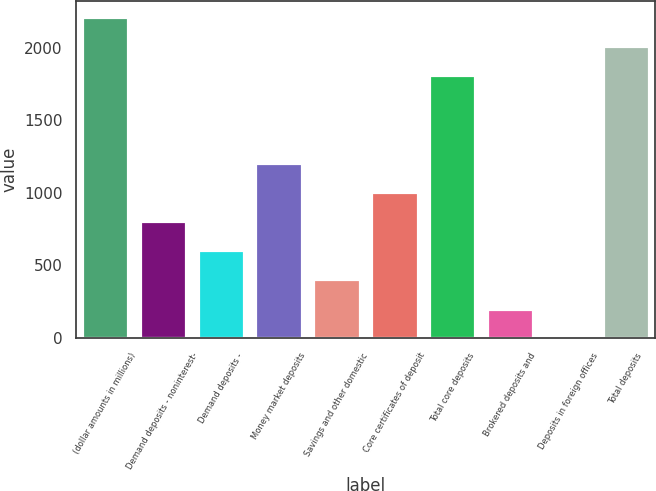Convert chart. <chart><loc_0><loc_0><loc_500><loc_500><bar_chart><fcel>(dollar amounts in millions)<fcel>Demand deposits - noninterest-<fcel>Demand deposits -<fcel>Money market deposits<fcel>Savings and other domestic<fcel>Core certificates of deposit<fcel>Total core deposits<fcel>Brokered deposits and<fcel>Deposits in foreign offices<fcel>Total deposits<nl><fcel>2210.9<fcel>804.6<fcel>603.7<fcel>1206.4<fcel>402.8<fcel>1005.5<fcel>1809.1<fcel>201.9<fcel>1<fcel>2010<nl></chart> 